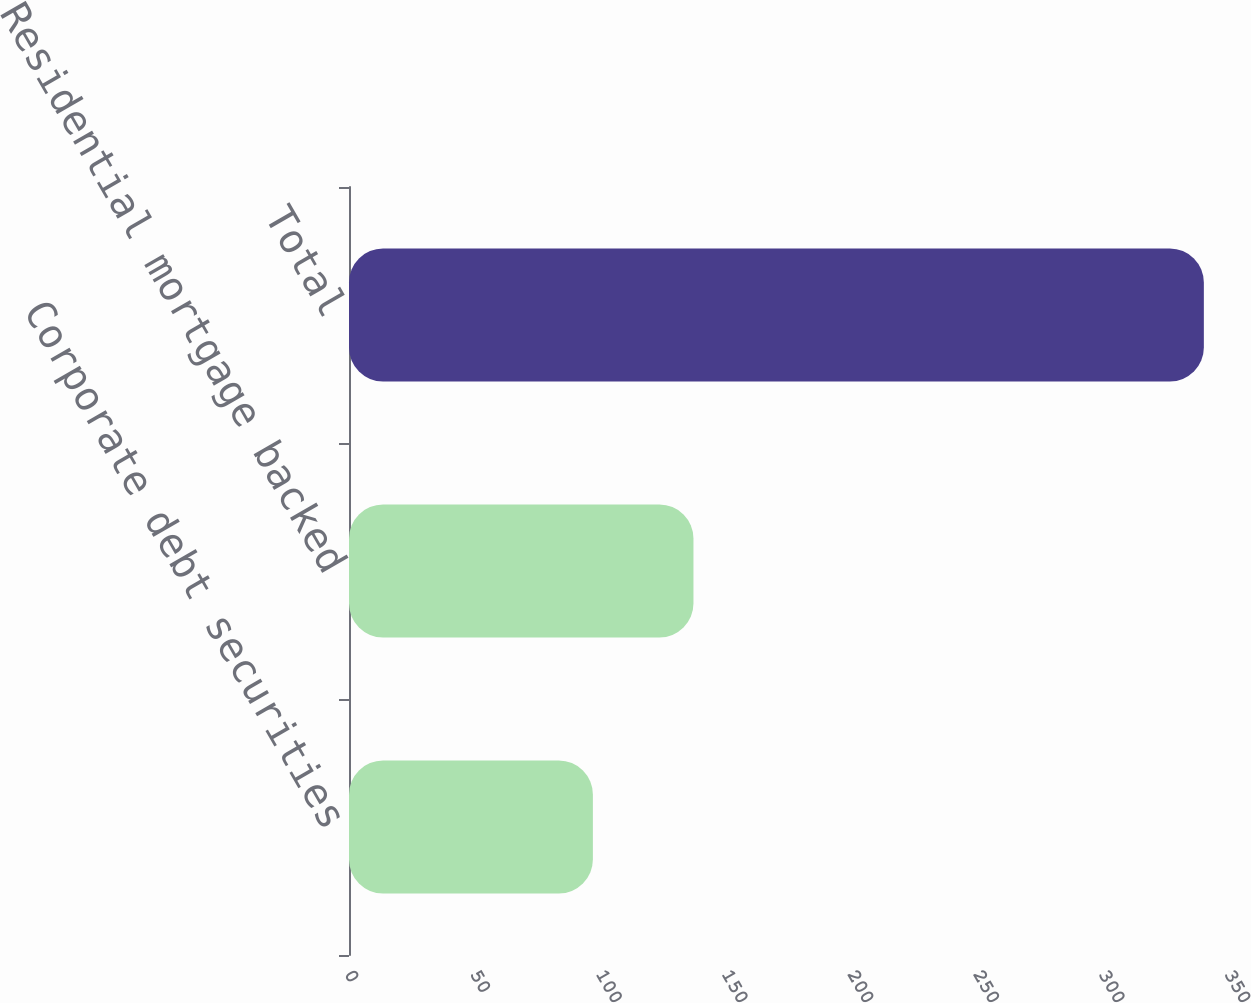<chart> <loc_0><loc_0><loc_500><loc_500><bar_chart><fcel>Corporate debt securities<fcel>Residential mortgage backed<fcel>Total<nl><fcel>97<fcel>137<fcel>340<nl></chart> 